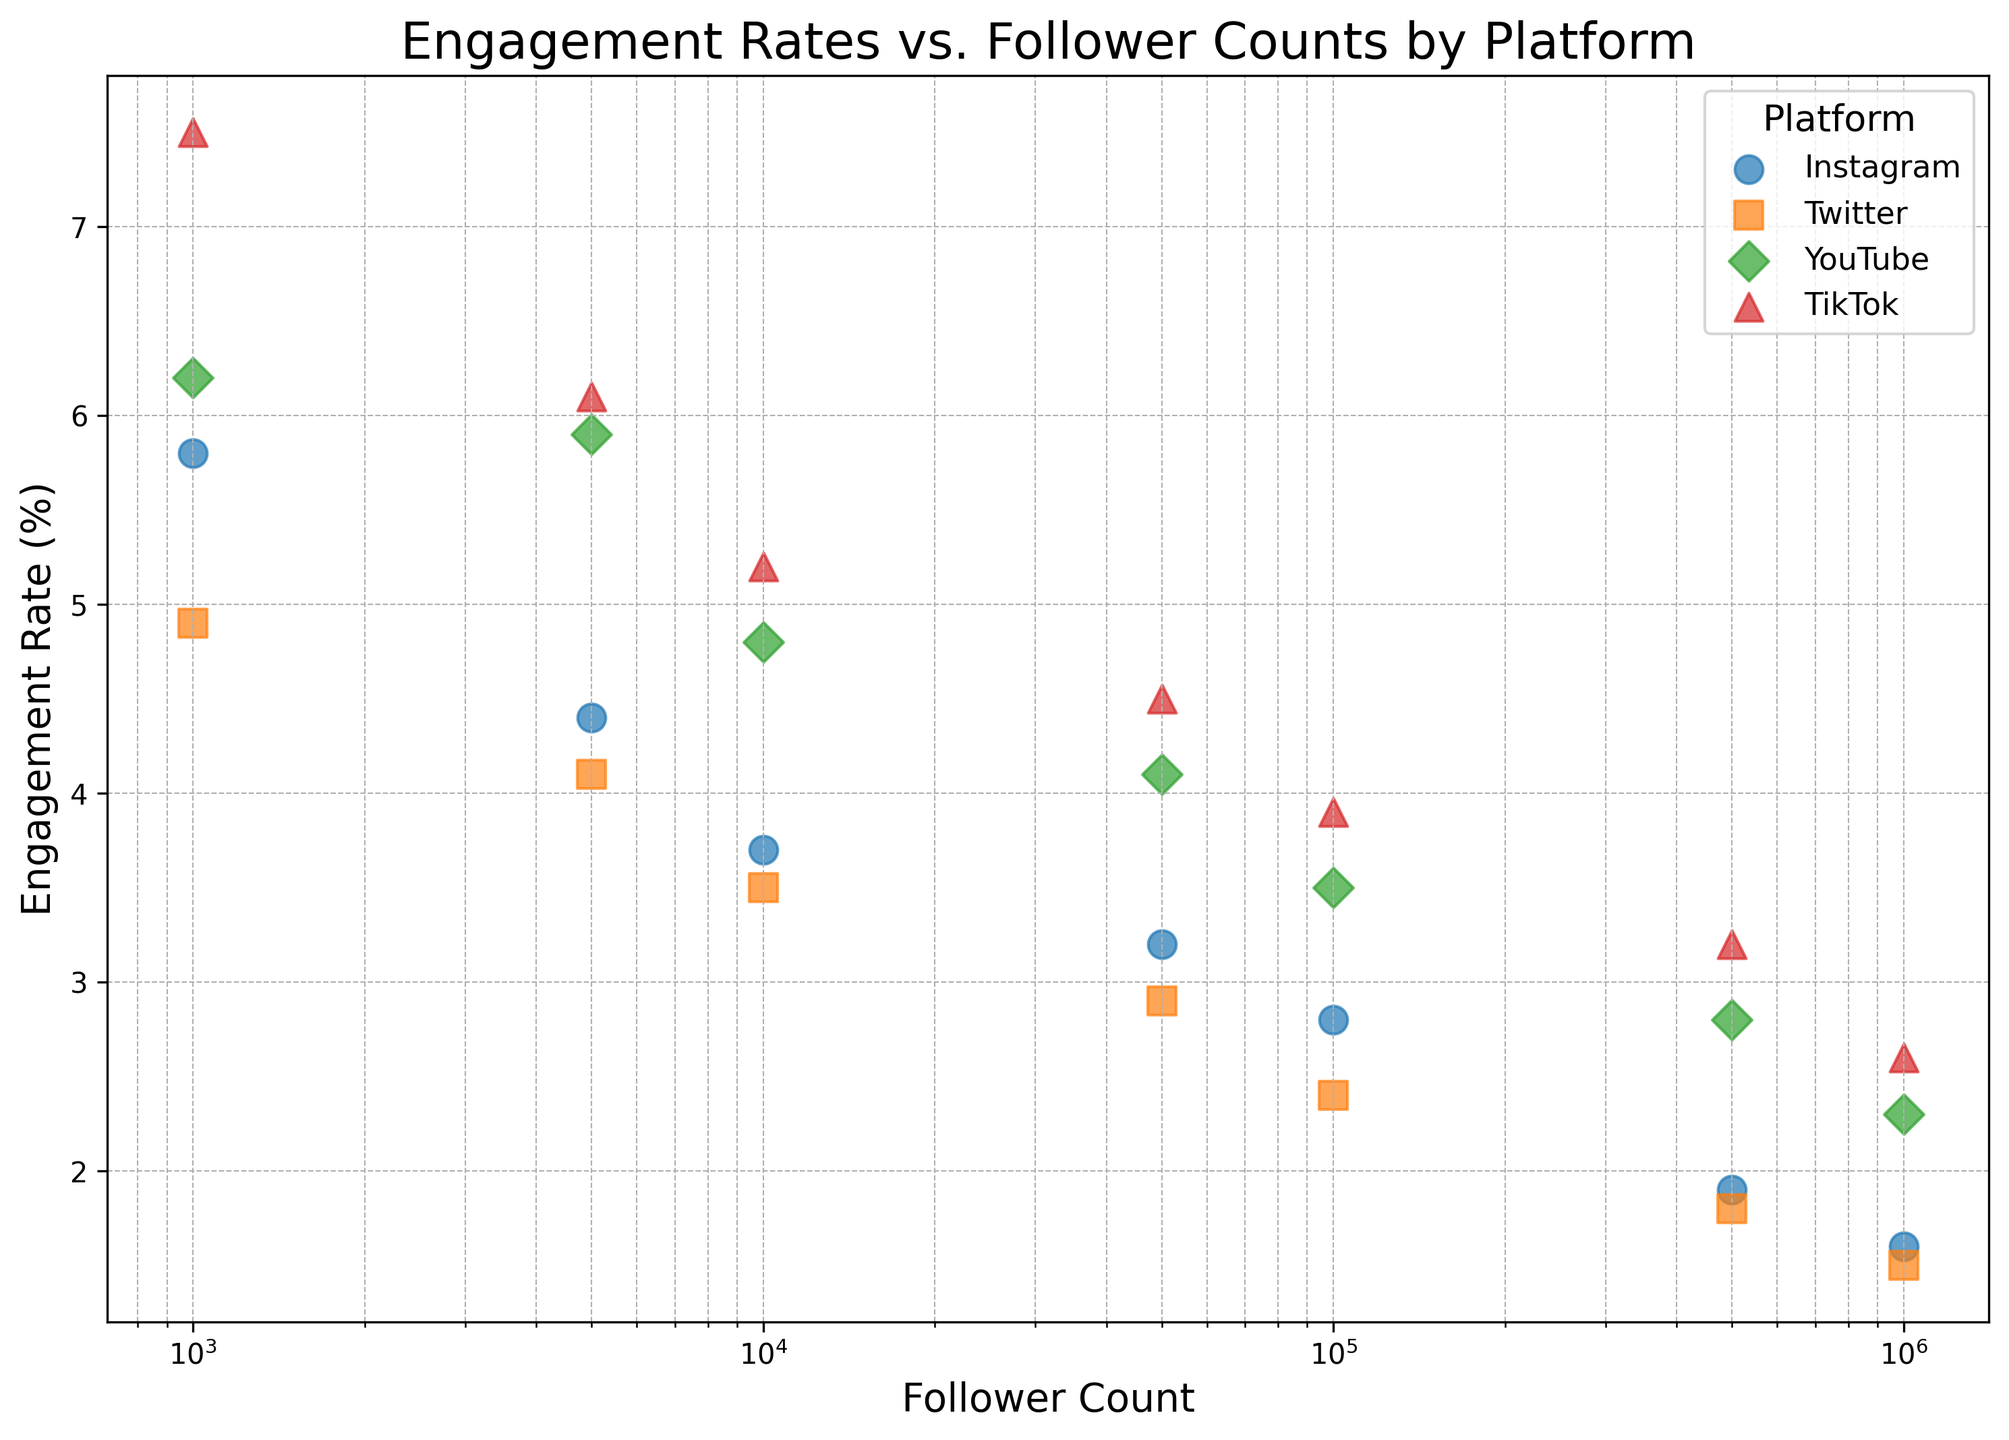What is the general trend of engagement rates as follower counts increase on Instagram? The engagement rates on Instagram generally decrease as follower counts increase, noticeable from the scatter plot as the points slope downward as you move right (higher follower counts).
Answer: Decreasing Which platform has the highest engagement rate for influencers with 1,000 followers? By examining the scatter plot, the influencer on TikTok has the highest engagement rate (7.5%) compared to influencers on other platforms with the same follower count.
Answer: TikTok Are there any platforms where engagement rates drop below 2% for influencers with 1,000,000 followers? By observing the scatter plot, all platforms show engagement rates below 2% for influencers with 1,000,000 followers: Instagram (1.6%), Twitter (1.5%), YouTube (2.3%), TikTok (2.6%).
Answer: Yes On which platform is the engagement rate the lowest for influencers with 10,000 followers? Checking the scatter plot, Twitter shows the lowest engagement rate (3.5%) for influencers with 10,000 followers.
Answer: Twitter What is the difference in engagement rates between Instagram and TikTok for influencers with 500,000 followers? Comparing the engagement rates for 500,000 followers, TikTok has 3.2% and Instagram has 1.9%. The difference is 3.2% - 1.9% = 1.3%.
Answer: 1.3% Which platform shows the steepest decline in engagement rates as follower count increases? Observing the scatter plot, TikTok shows the steepest decline; its engagement rate starts highest at 7.5% for 1,000 followers and drops to 2.6% for 1,000,000 followers, a greater range compared to other platforms.
Answer: TikTok At what follower count does YouTube's engagement rate intersect with Instagram's engagement rate? By checking the plotted points, YouTube and Instagram engagement rates intersect around the 500,000 follower mark, both showing an engagement rate close to 1.9%-2.0%.
Answer: 500,000 How does the engagement rate for TikTok influencers with 5,000 followers compare to the engagement rate of Twitter influencers with 50,000 followers? From the plot, TikTok influencers with 5,000 followers have an engagement rate of 6.1%, whereas Twitter influencers with 50,000 followers have an engagement rate of 2.9%. TikTok's engagement rate is higher.
Answer: TikTok higher What is the average engagement rate for influencers on YouTube across all follower counts displayed? Calculating the average: (6.2 + 5.9 + 4.8 + 4.1 + 3.5 + 2.8 + 2.3) / 7 = 29.6 / 7 ≈ 4.23%.
Answer: 4.23% Based on the plot, which platform shows the least variability in engagement rates across different follower counts? Visual examination of the scatter plot shows the least vertical spread of points on Twitter, indicating the smallest variation in engagement rates.
Answer: Twitter 